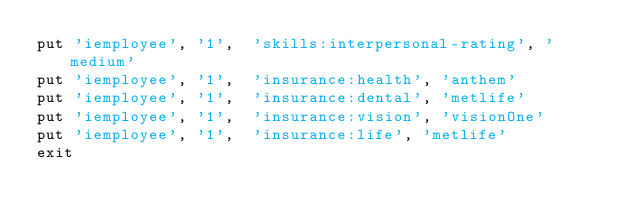Convert code to text. <code><loc_0><loc_0><loc_500><loc_500><_SQL_>put 'iemployee', '1',  'skills:interpersonal-rating', 'medium'
put 'iemployee', '1',  'insurance:health', 'anthem'
put 'iemployee', '1',  'insurance:dental', 'metlife' 
put 'iemployee', '1',  'insurance:vision', 'visionOne'
put 'iemployee', '1',  'insurance:life', 'metlife'
exit
</code> 